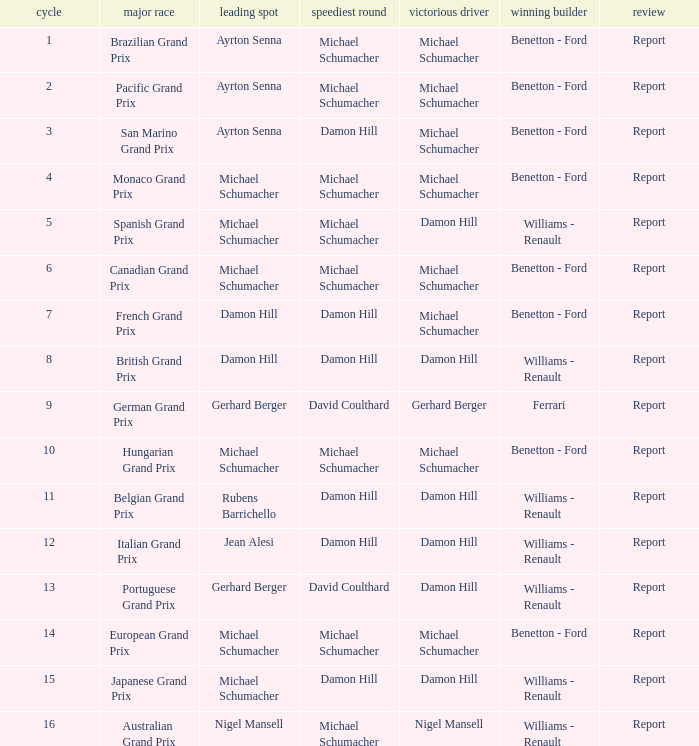Name the lowest round for when pole position and winning driver is michael schumacher 4.0. 